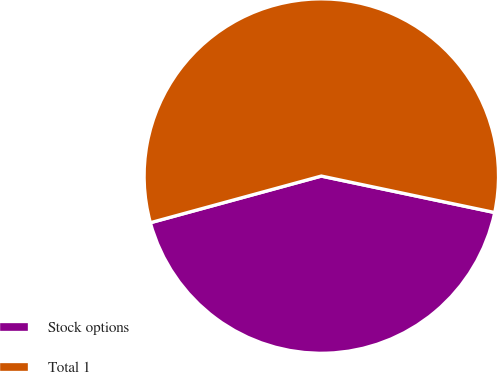<chart> <loc_0><loc_0><loc_500><loc_500><pie_chart><fcel>Stock options<fcel>Total 1<nl><fcel>42.46%<fcel>57.54%<nl></chart> 